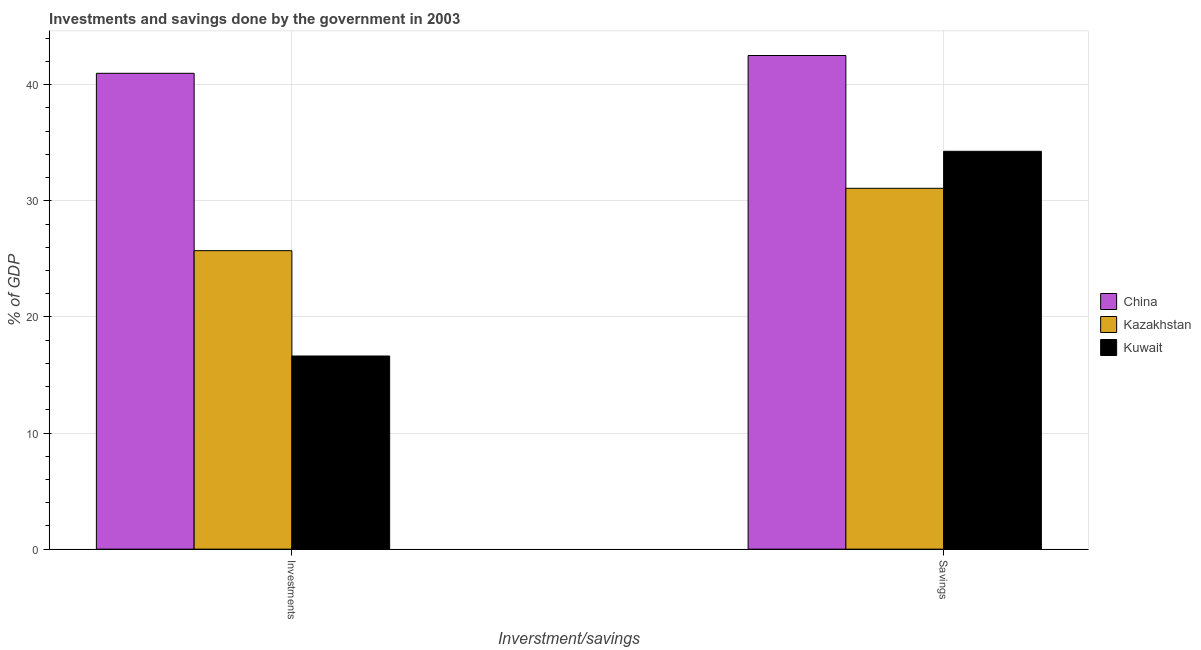How many different coloured bars are there?
Give a very brief answer. 3. Are the number of bars on each tick of the X-axis equal?
Make the answer very short. Yes. How many bars are there on the 1st tick from the left?
Provide a short and direct response. 3. How many bars are there on the 2nd tick from the right?
Make the answer very short. 3. What is the label of the 1st group of bars from the left?
Give a very brief answer. Investments. What is the savings of government in China?
Your answer should be very brief. 42.51. Across all countries, what is the maximum savings of government?
Your answer should be compact. 42.51. Across all countries, what is the minimum investments of government?
Provide a short and direct response. 16.63. In which country was the investments of government minimum?
Give a very brief answer. Kuwait. What is the total savings of government in the graph?
Make the answer very short. 107.85. What is the difference between the investments of government in Kuwait and that in Kazakhstan?
Your response must be concise. -9.07. What is the difference between the savings of government in Kazakhstan and the investments of government in Kuwait?
Your response must be concise. 14.44. What is the average savings of government per country?
Keep it short and to the point. 35.95. What is the difference between the savings of government and investments of government in China?
Your answer should be compact. 1.53. What is the ratio of the investments of government in China to that in Kazakhstan?
Give a very brief answer. 1.59. What does the 1st bar from the left in Savings represents?
Offer a terse response. China. What does the 2nd bar from the right in Savings represents?
Make the answer very short. Kazakhstan. What is the difference between two consecutive major ticks on the Y-axis?
Provide a short and direct response. 10. Does the graph contain grids?
Your answer should be very brief. Yes. How many legend labels are there?
Provide a succinct answer. 3. How are the legend labels stacked?
Provide a succinct answer. Vertical. What is the title of the graph?
Ensure brevity in your answer.  Investments and savings done by the government in 2003. Does "Solomon Islands" appear as one of the legend labels in the graph?
Offer a very short reply. No. What is the label or title of the X-axis?
Your answer should be very brief. Inverstment/savings. What is the label or title of the Y-axis?
Offer a terse response. % of GDP. What is the % of GDP of China in Investments?
Ensure brevity in your answer.  40.98. What is the % of GDP of Kazakhstan in Investments?
Provide a short and direct response. 25.7. What is the % of GDP in Kuwait in Investments?
Keep it short and to the point. 16.63. What is the % of GDP in China in Savings?
Ensure brevity in your answer.  42.51. What is the % of GDP in Kazakhstan in Savings?
Offer a very short reply. 31.07. What is the % of GDP in Kuwait in Savings?
Give a very brief answer. 34.26. Across all Inverstment/savings, what is the maximum % of GDP of China?
Offer a terse response. 42.51. Across all Inverstment/savings, what is the maximum % of GDP in Kazakhstan?
Offer a terse response. 31.07. Across all Inverstment/savings, what is the maximum % of GDP in Kuwait?
Ensure brevity in your answer.  34.26. Across all Inverstment/savings, what is the minimum % of GDP in China?
Ensure brevity in your answer.  40.98. Across all Inverstment/savings, what is the minimum % of GDP of Kazakhstan?
Your answer should be compact. 25.7. Across all Inverstment/savings, what is the minimum % of GDP in Kuwait?
Your response must be concise. 16.63. What is the total % of GDP of China in the graph?
Provide a succinct answer. 83.49. What is the total % of GDP in Kazakhstan in the graph?
Offer a terse response. 56.78. What is the total % of GDP in Kuwait in the graph?
Your answer should be compact. 50.89. What is the difference between the % of GDP of China in Investments and that in Savings?
Keep it short and to the point. -1.53. What is the difference between the % of GDP of Kazakhstan in Investments and that in Savings?
Your answer should be compact. -5.37. What is the difference between the % of GDP of Kuwait in Investments and that in Savings?
Make the answer very short. -17.63. What is the difference between the % of GDP of China in Investments and the % of GDP of Kazakhstan in Savings?
Ensure brevity in your answer.  9.9. What is the difference between the % of GDP in China in Investments and the % of GDP in Kuwait in Savings?
Provide a succinct answer. 6.72. What is the difference between the % of GDP of Kazakhstan in Investments and the % of GDP of Kuwait in Savings?
Your answer should be very brief. -8.56. What is the average % of GDP of China per Inverstment/savings?
Keep it short and to the point. 41.75. What is the average % of GDP of Kazakhstan per Inverstment/savings?
Your answer should be very brief. 28.39. What is the average % of GDP of Kuwait per Inverstment/savings?
Make the answer very short. 25.45. What is the difference between the % of GDP of China and % of GDP of Kazakhstan in Investments?
Give a very brief answer. 15.28. What is the difference between the % of GDP in China and % of GDP in Kuwait in Investments?
Your answer should be compact. 24.35. What is the difference between the % of GDP in Kazakhstan and % of GDP in Kuwait in Investments?
Provide a short and direct response. 9.07. What is the difference between the % of GDP of China and % of GDP of Kazakhstan in Savings?
Your response must be concise. 11.44. What is the difference between the % of GDP in China and % of GDP in Kuwait in Savings?
Your answer should be very brief. 8.25. What is the difference between the % of GDP in Kazakhstan and % of GDP in Kuwait in Savings?
Your answer should be very brief. -3.19. What is the ratio of the % of GDP of Kazakhstan in Investments to that in Savings?
Offer a terse response. 0.83. What is the ratio of the % of GDP of Kuwait in Investments to that in Savings?
Your answer should be compact. 0.49. What is the difference between the highest and the second highest % of GDP in China?
Keep it short and to the point. 1.53. What is the difference between the highest and the second highest % of GDP of Kazakhstan?
Make the answer very short. 5.37. What is the difference between the highest and the second highest % of GDP in Kuwait?
Provide a succinct answer. 17.63. What is the difference between the highest and the lowest % of GDP in China?
Your answer should be compact. 1.53. What is the difference between the highest and the lowest % of GDP of Kazakhstan?
Offer a terse response. 5.37. What is the difference between the highest and the lowest % of GDP in Kuwait?
Make the answer very short. 17.63. 